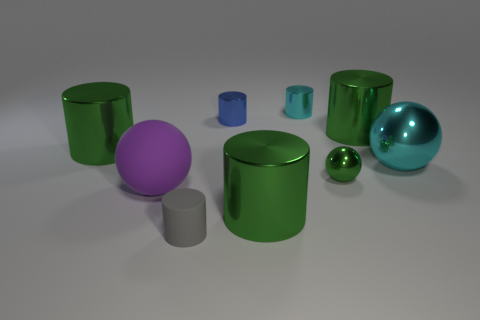Is there any other thing that has the same color as the tiny ball?
Ensure brevity in your answer.  Yes. Is the number of small rubber cylinders greater than the number of big green shiny things?
Offer a very short reply. No. Are the small cyan cylinder and the blue cylinder made of the same material?
Provide a succinct answer. Yes. How many small gray objects are the same material as the tiny blue object?
Ensure brevity in your answer.  0. There is a cyan cylinder; is its size the same as the matte object that is in front of the purple ball?
Offer a terse response. Yes. What is the color of the tiny thing that is on the left side of the cyan shiny cylinder and to the right of the tiny gray cylinder?
Your response must be concise. Blue. There is a big cylinder that is left of the blue cylinder; are there any metal things that are behind it?
Give a very brief answer. Yes. Is the number of tiny blue things that are to the right of the blue shiny cylinder the same as the number of small rubber things?
Your response must be concise. No. What number of metal objects are in front of the large green thing on the right side of the green ball behind the tiny matte object?
Your answer should be compact. 4. Are there any gray objects that have the same size as the matte cylinder?
Keep it short and to the point. No. 